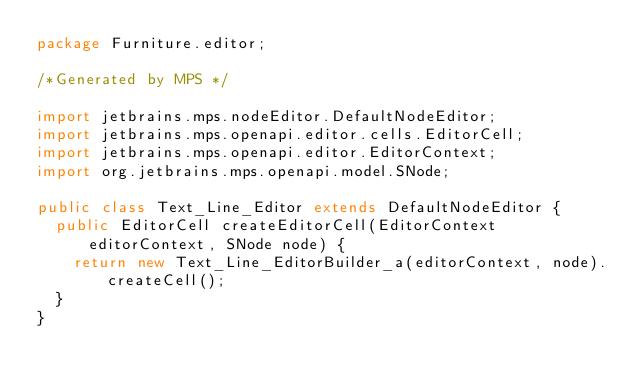Convert code to text. <code><loc_0><loc_0><loc_500><loc_500><_Java_>package Furniture.editor;

/*Generated by MPS */

import jetbrains.mps.nodeEditor.DefaultNodeEditor;
import jetbrains.mps.openapi.editor.cells.EditorCell;
import jetbrains.mps.openapi.editor.EditorContext;
import org.jetbrains.mps.openapi.model.SNode;

public class Text_Line_Editor extends DefaultNodeEditor {
  public EditorCell createEditorCell(EditorContext editorContext, SNode node) {
    return new Text_Line_EditorBuilder_a(editorContext, node).createCell();
  }
}
</code> 